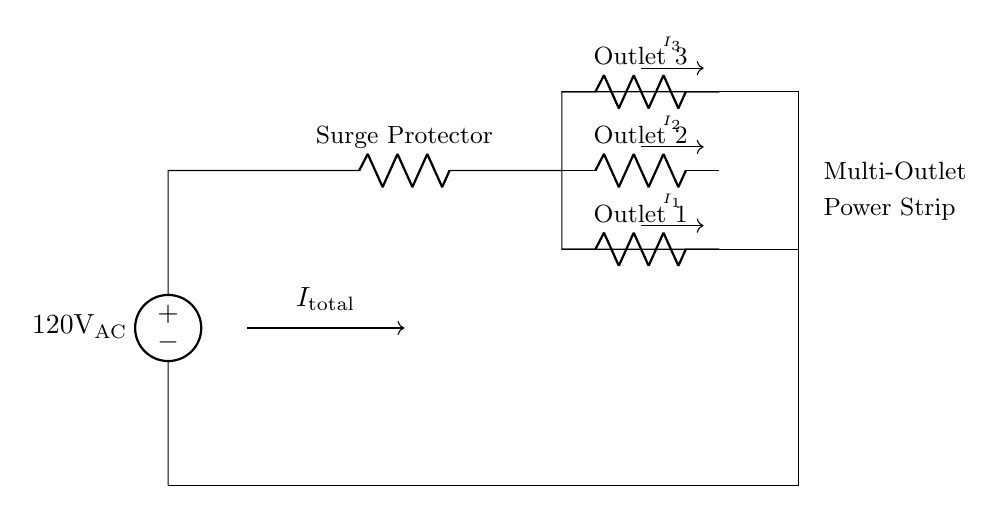What is the input voltage of the circuit? The input voltage is 120 volts AC, as indicated by the voltage source labeled at the beginning of the circuit.
Answer: 120 volts AC How many outlets are in the power strip? There are three outlets shown in the circuit diagram, each represented by a resistor labeled as Outlet 1, Outlet 2, and Outlet 3.
Answer: Three What does the surge protector do in this circuit? The surge protector serves to protect the circuit from voltage spikes or surges. It is typically designed to absorb extra voltage and prevent damage to connected devices.
Answer: Protect from surges If the total current entering the circuit is ten amps, what is the current through Outlet 1? In a current divider circuit, the current through Outlet 1 depends on its resistance relative to the others. Assuming equal resistances for the outlets, each will carry one-third of the total current. Therefore, for ten amps, Outlet 1 would carry approximately 3.33 amps.
Answer: 3.33 amps What type of circuit is represented in the diagram? This is a current divider circuit, as it splits the total input current into smaller currents through the parallel outlets. Each outlet experiences a portion of the total current based on its resistance.
Answer: Current divider What kind of devices can be plugged into this power strip? Generally, any devices that can operate on standard 120 volts AC can be plugged in, such as computers, printers, and chargers.
Answer: Computers, printers, chargers How is the current distributed among the outlets? The current is distributed based on the resistor values of each outlet. In a simple case where the resistances are equal, the current splits evenly, while differing resistance values would affect how much current each outlet receives.
Answer: Based on resistance values 